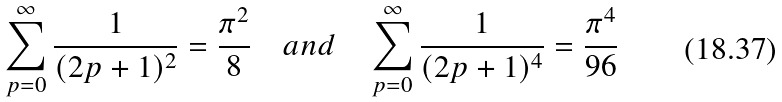<formula> <loc_0><loc_0><loc_500><loc_500>\sum _ { p = 0 } ^ { \infty } \frac { 1 } { ( 2 p + 1 ) ^ { 2 } } = \frac { \pi ^ { 2 } } { 8 } \quad a n d \quad \sum _ { p = 0 } ^ { \infty } \frac { 1 } { ( 2 p + 1 ) ^ { 4 } } = \frac { \pi ^ { 4 } } { 9 6 }</formula> 